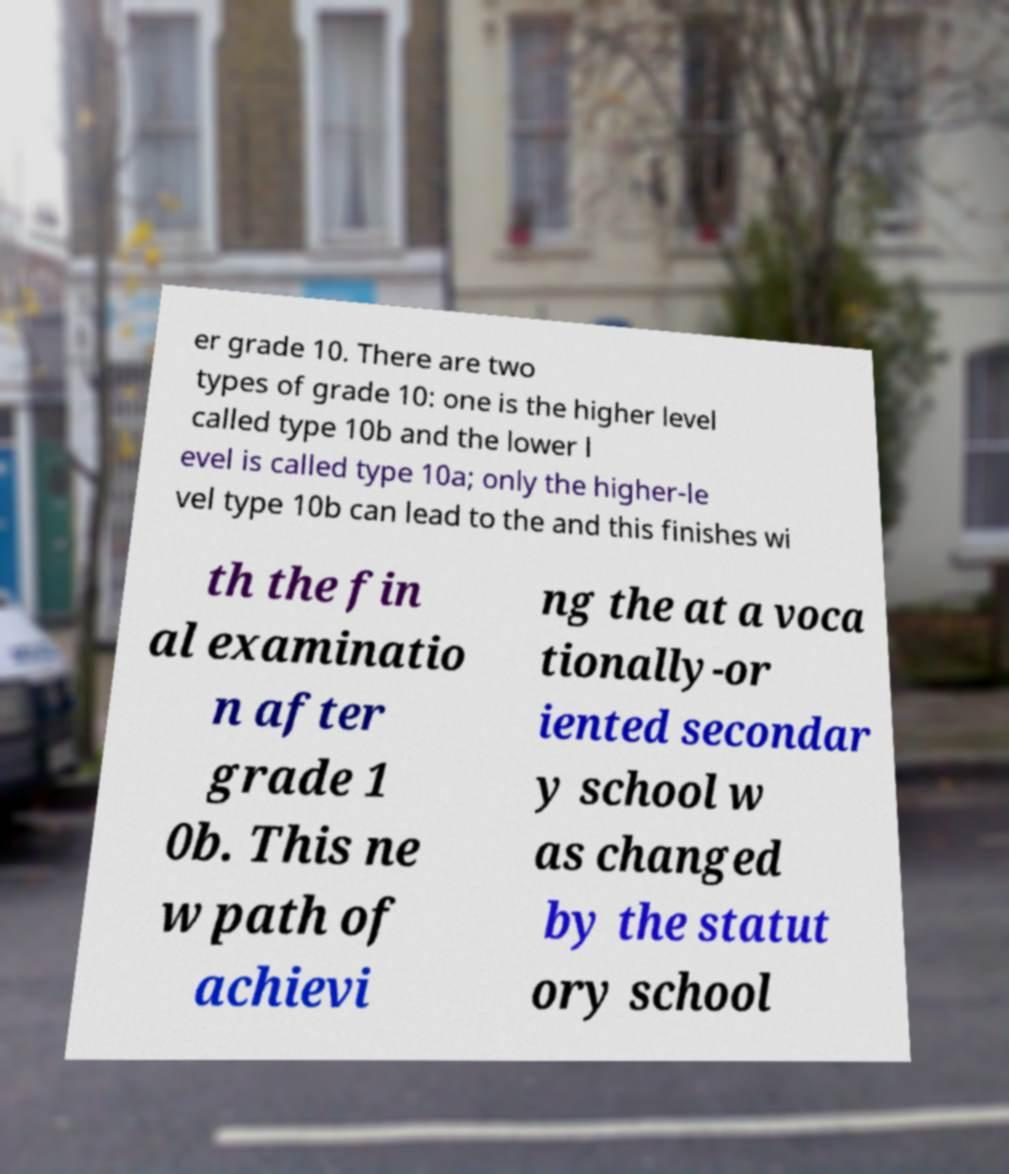For documentation purposes, I need the text within this image transcribed. Could you provide that? er grade 10. There are two types of grade 10: one is the higher level called type 10b and the lower l evel is called type 10a; only the higher-le vel type 10b can lead to the and this finishes wi th the fin al examinatio n after grade 1 0b. This ne w path of achievi ng the at a voca tionally-or iented secondar y school w as changed by the statut ory school 